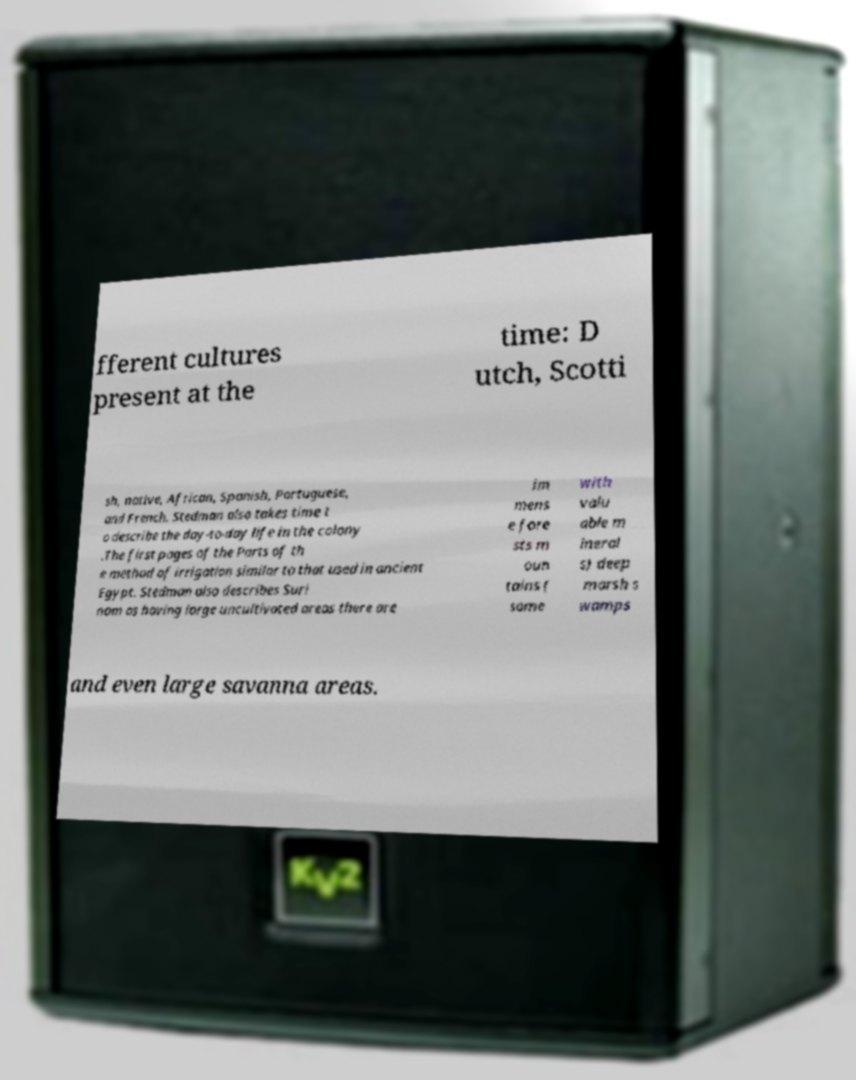Please identify and transcribe the text found in this image. fferent cultures present at the time: D utch, Scotti sh, native, African, Spanish, Portuguese, and French. Stedman also takes time t o describe the day-to-day life in the colony .The first pages of the Parts of th e method of irrigation similar to that used in ancient Egypt. Stedman also describes Suri nam as having large uncultivated areas there are im mens e fore sts m oun tains ( some with valu able m ineral s) deep marsh s wamps and even large savanna areas. 